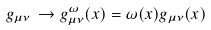<formula> <loc_0><loc_0><loc_500><loc_500>g _ { \mu \nu } \, \to g ^ { \omega } _ { \mu \nu } ( x ) = \omega ( x ) g _ { \mu \nu } ( x )</formula> 